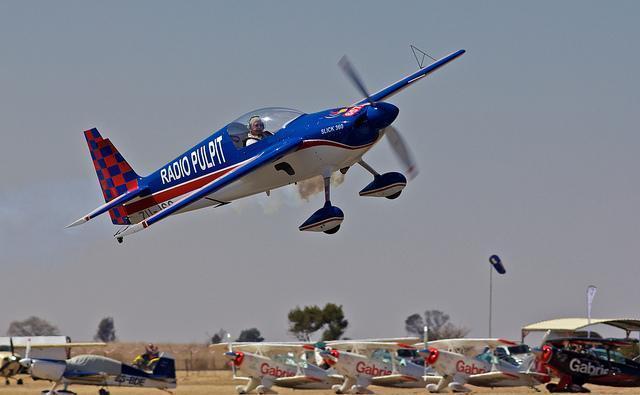How many people are in the plane?
Give a very brief answer. 1. How many airplanes are in the picture?
Give a very brief answer. 6. 